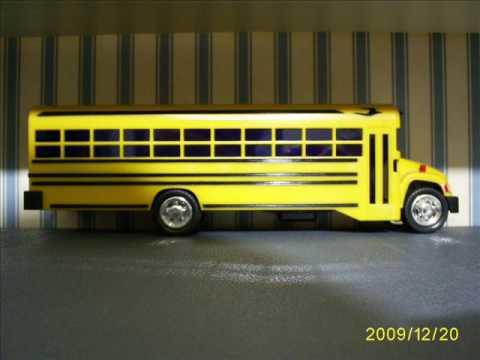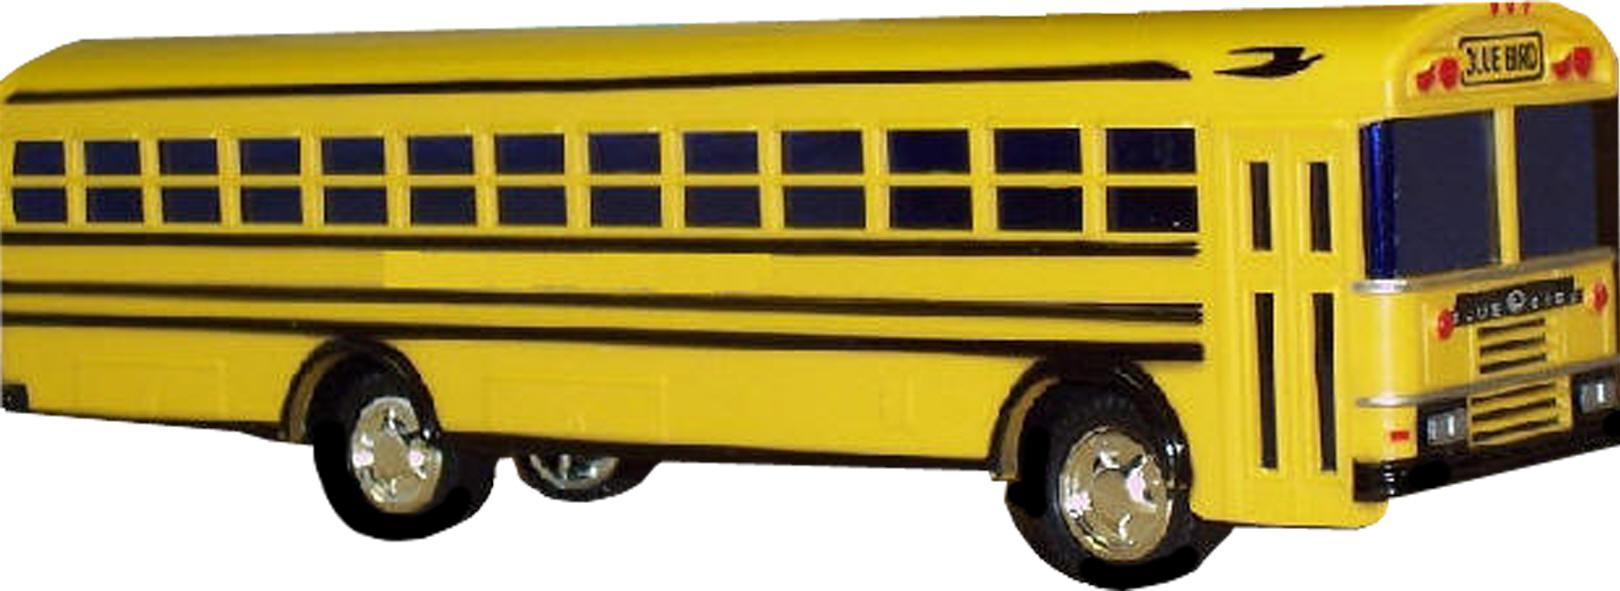The first image is the image on the left, the second image is the image on the right. Given the left and right images, does the statement "A bus' left side is visible." hold true? Answer yes or no. No. The first image is the image on the left, the second image is the image on the right. Examine the images to the left and right. Is the description "At least one bus has a red stop sign." accurate? Answer yes or no. No. 